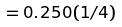<formula> <loc_0><loc_0><loc_500><loc_500>= 0 . 2 5 0 ( 1 / 4 )</formula> 